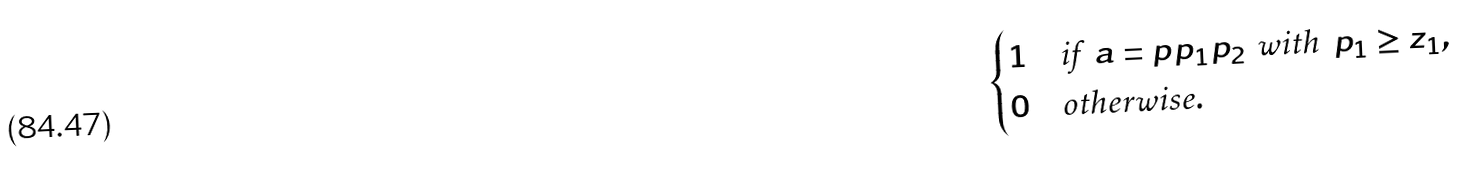Convert formula to latex. <formula><loc_0><loc_0><loc_500><loc_500>\begin{cases} 1 & \text {if } \, a = p p _ { 1 } p _ { 2 } \, \text { with } \, p _ { 1 } \geq z _ { 1 } , \\ 0 & \text {otherwise} . \end{cases}</formula> 